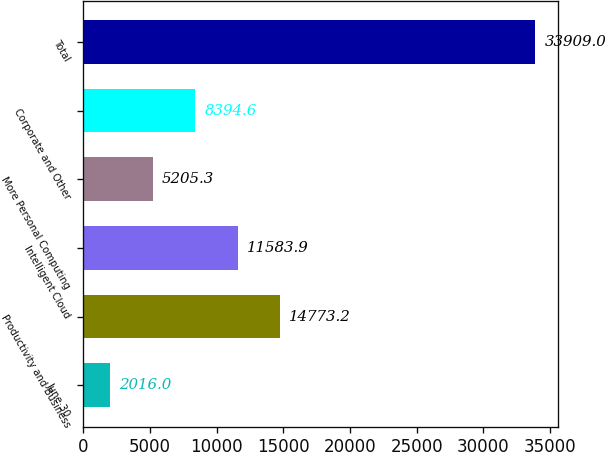Convert chart to OTSL. <chart><loc_0><loc_0><loc_500><loc_500><bar_chart><fcel>June 30<fcel>Productivity and Business<fcel>Intelligent Cloud<fcel>More Personal Computing<fcel>Corporate and Other<fcel>Total<nl><fcel>2016<fcel>14773.2<fcel>11583.9<fcel>5205.3<fcel>8394.6<fcel>33909<nl></chart> 